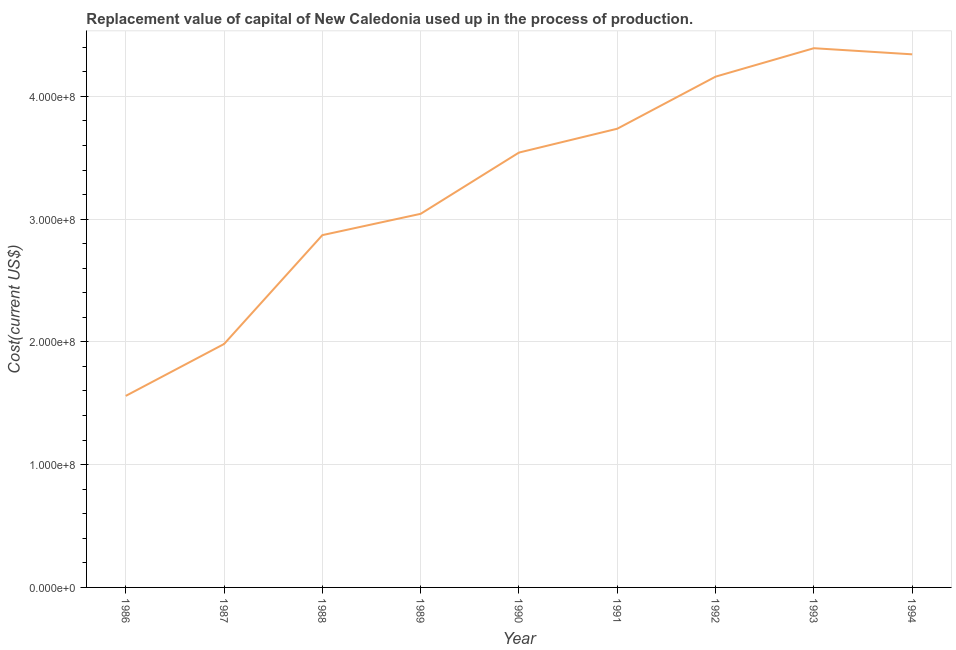What is the consumption of fixed capital in 1993?
Your answer should be very brief. 4.39e+08. Across all years, what is the maximum consumption of fixed capital?
Your answer should be very brief. 4.39e+08. Across all years, what is the minimum consumption of fixed capital?
Your answer should be compact. 1.56e+08. In which year was the consumption of fixed capital maximum?
Offer a very short reply. 1993. What is the sum of the consumption of fixed capital?
Offer a terse response. 2.96e+09. What is the difference between the consumption of fixed capital in 1986 and 1987?
Your answer should be very brief. -4.23e+07. What is the average consumption of fixed capital per year?
Give a very brief answer. 3.29e+08. What is the median consumption of fixed capital?
Make the answer very short. 3.54e+08. Do a majority of the years between 1988 and 1992 (inclusive) have consumption of fixed capital greater than 340000000 US$?
Offer a terse response. Yes. What is the ratio of the consumption of fixed capital in 1988 to that in 1991?
Offer a terse response. 0.77. Is the consumption of fixed capital in 1986 less than that in 1990?
Your answer should be very brief. Yes. What is the difference between the highest and the second highest consumption of fixed capital?
Provide a short and direct response. 4.98e+06. Is the sum of the consumption of fixed capital in 1987 and 1991 greater than the maximum consumption of fixed capital across all years?
Ensure brevity in your answer.  Yes. What is the difference between the highest and the lowest consumption of fixed capital?
Provide a short and direct response. 2.83e+08. In how many years, is the consumption of fixed capital greater than the average consumption of fixed capital taken over all years?
Your response must be concise. 5. Does the consumption of fixed capital monotonically increase over the years?
Keep it short and to the point. No. Does the graph contain any zero values?
Make the answer very short. No. What is the title of the graph?
Your response must be concise. Replacement value of capital of New Caledonia used up in the process of production. What is the label or title of the Y-axis?
Keep it short and to the point. Cost(current US$). What is the Cost(current US$) in 1986?
Your response must be concise. 1.56e+08. What is the Cost(current US$) in 1987?
Your response must be concise. 1.98e+08. What is the Cost(current US$) in 1988?
Provide a short and direct response. 2.87e+08. What is the Cost(current US$) of 1989?
Give a very brief answer. 3.04e+08. What is the Cost(current US$) of 1990?
Make the answer very short. 3.54e+08. What is the Cost(current US$) of 1991?
Offer a very short reply. 3.74e+08. What is the Cost(current US$) in 1992?
Your response must be concise. 4.16e+08. What is the Cost(current US$) of 1993?
Your answer should be very brief. 4.39e+08. What is the Cost(current US$) of 1994?
Offer a terse response. 4.34e+08. What is the difference between the Cost(current US$) in 1986 and 1987?
Make the answer very short. -4.23e+07. What is the difference between the Cost(current US$) in 1986 and 1988?
Offer a terse response. -1.31e+08. What is the difference between the Cost(current US$) in 1986 and 1989?
Your response must be concise. -1.48e+08. What is the difference between the Cost(current US$) in 1986 and 1990?
Provide a short and direct response. -1.98e+08. What is the difference between the Cost(current US$) in 1986 and 1991?
Make the answer very short. -2.18e+08. What is the difference between the Cost(current US$) in 1986 and 1992?
Make the answer very short. -2.60e+08. What is the difference between the Cost(current US$) in 1986 and 1993?
Ensure brevity in your answer.  -2.83e+08. What is the difference between the Cost(current US$) in 1986 and 1994?
Your answer should be compact. -2.78e+08. What is the difference between the Cost(current US$) in 1987 and 1988?
Provide a short and direct response. -8.87e+07. What is the difference between the Cost(current US$) in 1987 and 1989?
Make the answer very short. -1.06e+08. What is the difference between the Cost(current US$) in 1987 and 1990?
Ensure brevity in your answer.  -1.56e+08. What is the difference between the Cost(current US$) in 1987 and 1991?
Offer a very short reply. -1.75e+08. What is the difference between the Cost(current US$) in 1987 and 1992?
Offer a very short reply. -2.18e+08. What is the difference between the Cost(current US$) in 1987 and 1993?
Your answer should be compact. -2.41e+08. What is the difference between the Cost(current US$) in 1987 and 1994?
Your answer should be very brief. -2.36e+08. What is the difference between the Cost(current US$) in 1988 and 1989?
Give a very brief answer. -1.74e+07. What is the difference between the Cost(current US$) in 1988 and 1990?
Make the answer very short. -6.73e+07. What is the difference between the Cost(current US$) in 1988 and 1991?
Provide a succinct answer. -8.67e+07. What is the difference between the Cost(current US$) in 1988 and 1992?
Keep it short and to the point. -1.29e+08. What is the difference between the Cost(current US$) in 1988 and 1993?
Your response must be concise. -1.52e+08. What is the difference between the Cost(current US$) in 1988 and 1994?
Your answer should be compact. -1.47e+08. What is the difference between the Cost(current US$) in 1989 and 1990?
Provide a succinct answer. -4.99e+07. What is the difference between the Cost(current US$) in 1989 and 1991?
Keep it short and to the point. -6.93e+07. What is the difference between the Cost(current US$) in 1989 and 1992?
Offer a terse response. -1.12e+08. What is the difference between the Cost(current US$) in 1989 and 1993?
Your response must be concise. -1.35e+08. What is the difference between the Cost(current US$) in 1989 and 1994?
Ensure brevity in your answer.  -1.30e+08. What is the difference between the Cost(current US$) in 1990 and 1991?
Your answer should be very brief. -1.94e+07. What is the difference between the Cost(current US$) in 1990 and 1992?
Provide a short and direct response. -6.18e+07. What is the difference between the Cost(current US$) in 1990 and 1993?
Your response must be concise. -8.50e+07. What is the difference between the Cost(current US$) in 1990 and 1994?
Your answer should be very brief. -8.00e+07. What is the difference between the Cost(current US$) in 1991 and 1992?
Your answer should be compact. -4.24e+07. What is the difference between the Cost(current US$) in 1991 and 1993?
Offer a terse response. -6.56e+07. What is the difference between the Cost(current US$) in 1991 and 1994?
Provide a succinct answer. -6.06e+07. What is the difference between the Cost(current US$) in 1992 and 1993?
Provide a short and direct response. -2.32e+07. What is the difference between the Cost(current US$) in 1992 and 1994?
Ensure brevity in your answer.  -1.82e+07. What is the difference between the Cost(current US$) in 1993 and 1994?
Offer a terse response. 4.98e+06. What is the ratio of the Cost(current US$) in 1986 to that in 1987?
Offer a terse response. 0.79. What is the ratio of the Cost(current US$) in 1986 to that in 1988?
Your answer should be compact. 0.54. What is the ratio of the Cost(current US$) in 1986 to that in 1989?
Offer a terse response. 0.51. What is the ratio of the Cost(current US$) in 1986 to that in 1990?
Provide a succinct answer. 0.44. What is the ratio of the Cost(current US$) in 1986 to that in 1991?
Your response must be concise. 0.42. What is the ratio of the Cost(current US$) in 1986 to that in 1993?
Ensure brevity in your answer.  0.35. What is the ratio of the Cost(current US$) in 1986 to that in 1994?
Give a very brief answer. 0.36. What is the ratio of the Cost(current US$) in 1987 to that in 1988?
Your answer should be compact. 0.69. What is the ratio of the Cost(current US$) in 1987 to that in 1989?
Give a very brief answer. 0.65. What is the ratio of the Cost(current US$) in 1987 to that in 1990?
Provide a succinct answer. 0.56. What is the ratio of the Cost(current US$) in 1987 to that in 1991?
Ensure brevity in your answer.  0.53. What is the ratio of the Cost(current US$) in 1987 to that in 1992?
Your answer should be very brief. 0.48. What is the ratio of the Cost(current US$) in 1987 to that in 1993?
Offer a very short reply. 0.45. What is the ratio of the Cost(current US$) in 1987 to that in 1994?
Keep it short and to the point. 0.46. What is the ratio of the Cost(current US$) in 1988 to that in 1989?
Give a very brief answer. 0.94. What is the ratio of the Cost(current US$) in 1988 to that in 1990?
Your answer should be compact. 0.81. What is the ratio of the Cost(current US$) in 1988 to that in 1991?
Your answer should be compact. 0.77. What is the ratio of the Cost(current US$) in 1988 to that in 1992?
Provide a succinct answer. 0.69. What is the ratio of the Cost(current US$) in 1988 to that in 1993?
Provide a short and direct response. 0.65. What is the ratio of the Cost(current US$) in 1988 to that in 1994?
Your answer should be very brief. 0.66. What is the ratio of the Cost(current US$) in 1989 to that in 1990?
Ensure brevity in your answer.  0.86. What is the ratio of the Cost(current US$) in 1989 to that in 1991?
Ensure brevity in your answer.  0.81. What is the ratio of the Cost(current US$) in 1989 to that in 1992?
Provide a short and direct response. 0.73. What is the ratio of the Cost(current US$) in 1989 to that in 1993?
Provide a short and direct response. 0.69. What is the ratio of the Cost(current US$) in 1989 to that in 1994?
Your response must be concise. 0.7. What is the ratio of the Cost(current US$) in 1990 to that in 1991?
Make the answer very short. 0.95. What is the ratio of the Cost(current US$) in 1990 to that in 1992?
Provide a succinct answer. 0.85. What is the ratio of the Cost(current US$) in 1990 to that in 1993?
Your answer should be very brief. 0.81. What is the ratio of the Cost(current US$) in 1990 to that in 1994?
Your answer should be compact. 0.82. What is the ratio of the Cost(current US$) in 1991 to that in 1992?
Make the answer very short. 0.9. What is the ratio of the Cost(current US$) in 1991 to that in 1993?
Your response must be concise. 0.85. What is the ratio of the Cost(current US$) in 1991 to that in 1994?
Your response must be concise. 0.86. What is the ratio of the Cost(current US$) in 1992 to that in 1993?
Ensure brevity in your answer.  0.95. What is the ratio of the Cost(current US$) in 1992 to that in 1994?
Your answer should be very brief. 0.96. 